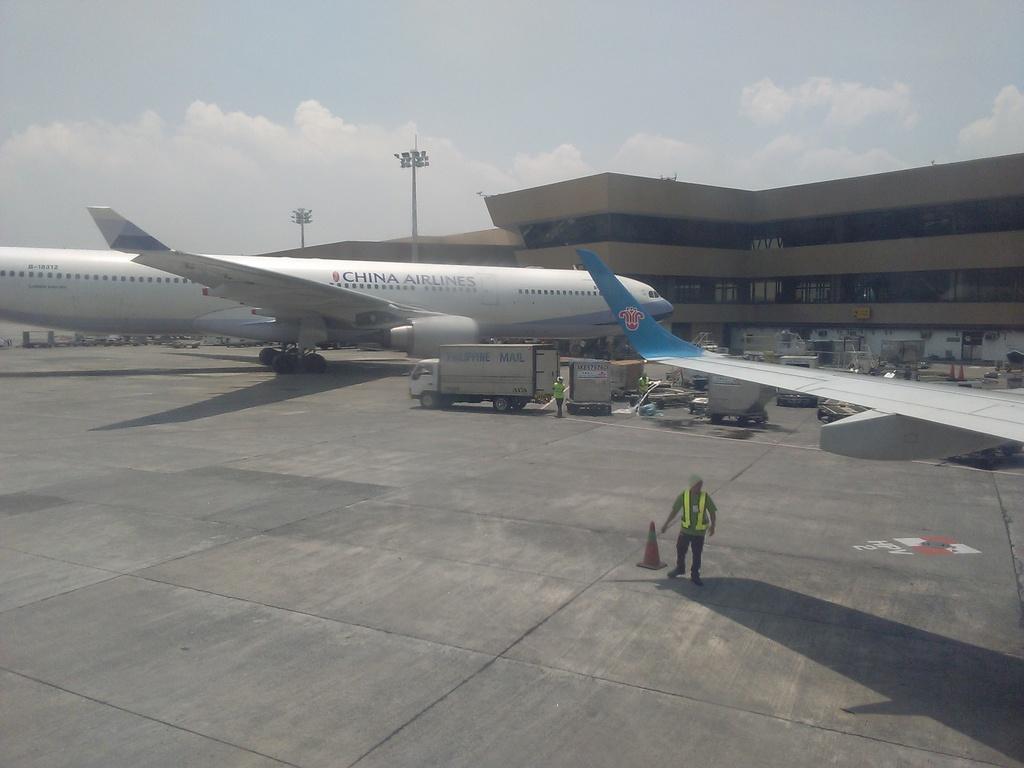Describe this image in one or two sentences. In this image there is the sky towards the top of the image, there are clouds in the sky, there is a building towards the right the image, there are poles, there are lights, there is an airplane, there is text on the airplane, there is ground towards the bottom of the image, there is a man walking, there is a person standing, there are vehicles on the ground, there are objects on the ground, there is an airplane wing towards the right of the image. 